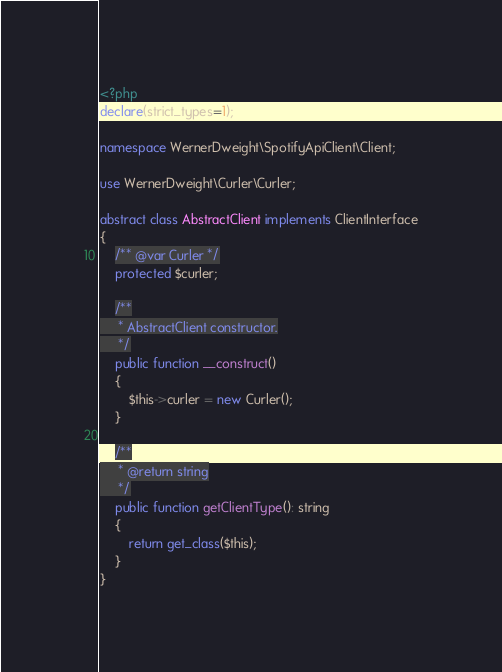Convert code to text. <code><loc_0><loc_0><loc_500><loc_500><_PHP_><?php
declare(strict_types=1);

namespace WernerDweight\SpotifyApiClient\Client;

use WernerDweight\Curler\Curler;

abstract class AbstractClient implements ClientInterface
{
    /** @var Curler */
    protected $curler;

    /**
     * AbstractClient constructor.
     */
    public function __construct()
    {
        $this->curler = new Curler();
    }

    /**
     * @return string
     */
    public function getClientType(): string
    {
        return get_class($this);
    }
}
</code> 